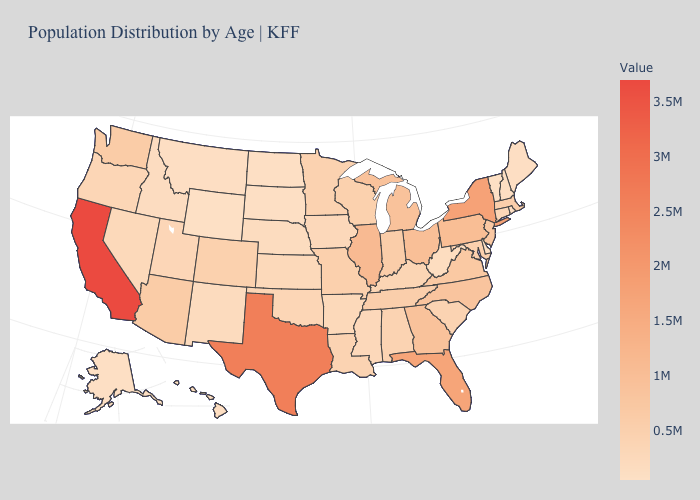Does Georgia have a lower value than Texas?
Concise answer only. Yes. Does Alaska have the lowest value in the West?
Give a very brief answer. No. Which states have the lowest value in the South?
Be succinct. Delaware. Is the legend a continuous bar?
Concise answer only. Yes. Which states hav the highest value in the West?
Quick response, please. California. Does Louisiana have a higher value than Illinois?
Quick response, please. No. Which states have the highest value in the USA?
Give a very brief answer. California. 